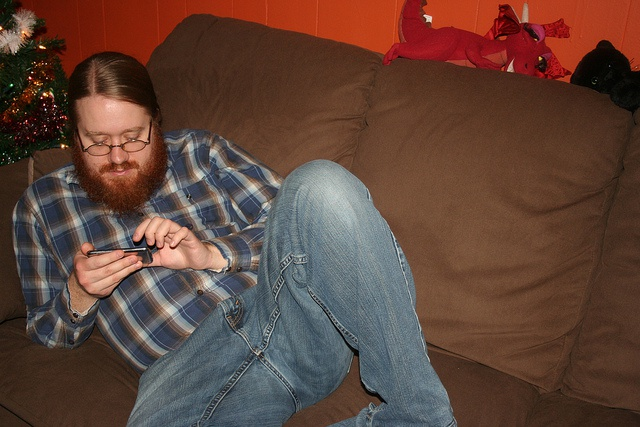Describe the objects in this image and their specific colors. I can see couch in black, maroon, brown, and gray tones, people in black, gray, and darkgray tones, teddy bear in black, brown, maroon, and gray tones, and cell phone in black, brown, maroon, and gray tones in this image. 